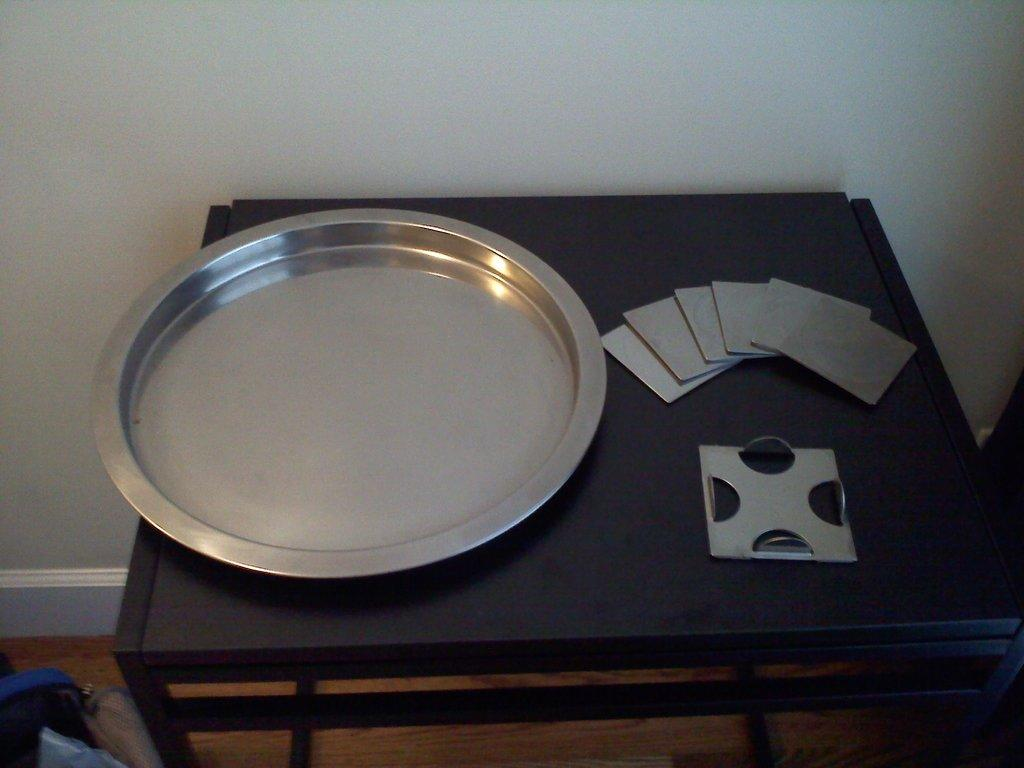What is the main object in the center of the image? There is a table in the center of the image. What is placed on the table? There is a plate placed on the table. What can be seen in the background of the image? There is a wall in the background of the image. What arithmetic problem is being solved on the table in the image? There is no arithmetic problem visible in the image; it only features a table and a plate. Can you see any fangs on the plate in the image? There are no fangs present on the plate or anywhere else in the image. 